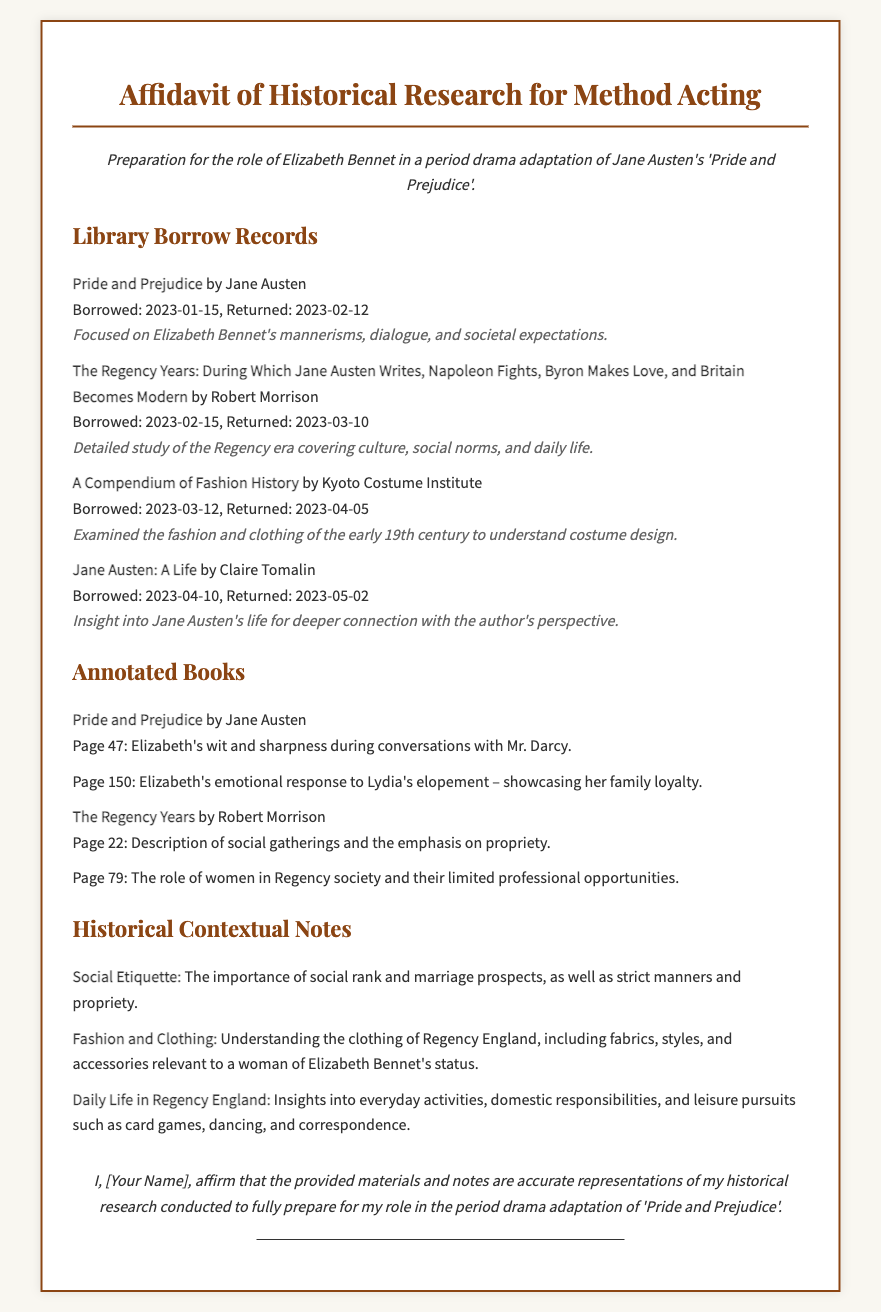What is the title of the affidavit? The title of the affidavit is the heading of the document, which identifies its purpose.
Answer: Affidavit of Historical Research for Method Acting Who is preparing for a role in the affidavit? The person preparing for the role is mentioned in the document, specifically related to the character in the drama.
Answer: Elizabeth Bennet What book was borrowed on 2023-01-15? This question asks for the specific title of the book listed under library borrow records with the corresponding borrow date.
Answer: Pride and Prejudice What is one of the social contextual notes mentioned? This question requires identifying a specific aspect of the historical context related to social etiquette.
Answer: The importance of social rank and marriage prospects Which annotated book includes a note about Elizabeth's emotional response? The answer requires connecting an annotated book with a specific page noting Elizabeth's reaction.
Answer: Pride and Prejudice How many library borrow records are listed in the document? The total number of library borrow records provides quantitative information from the relevant section of the document.
Answer: Four What is the name of the author of "A Compendium of Fashion History"? The question seeks the name of the author provided in the library borrow records.
Answer: Kyoto Costume Institute What aspect of daily life does the historical notes cover? This question focuses on summaries found in the historical context section, highlighting a particular area.
Answer: Everyday activities What is the status of the signature line in the document? The signature line indicates that the individual will affirm their research through the signatory line presented at the end of the affidavit.
Answer: Blank 